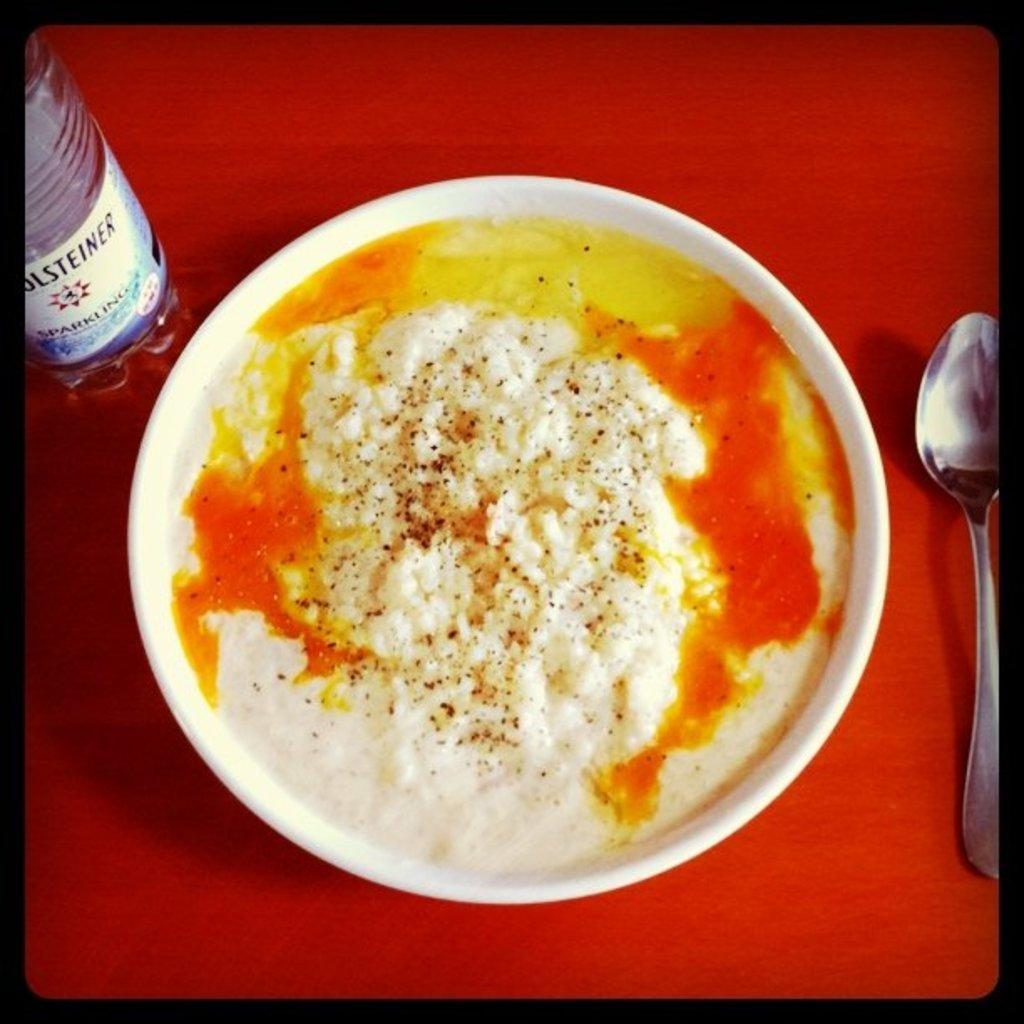What is in the bowl that is visible in the image? There is a bowl of food in the image. What other items can be seen on the table in the image? There is a water bottle and a spoon visible in the image. Where are these items located in the image? All of these items are on a table. What type of beast can be seen pulling the truck in the image? There is no beast or truck present in the image; it only features a bowl of food, a water bottle, and a spoon on a table. 